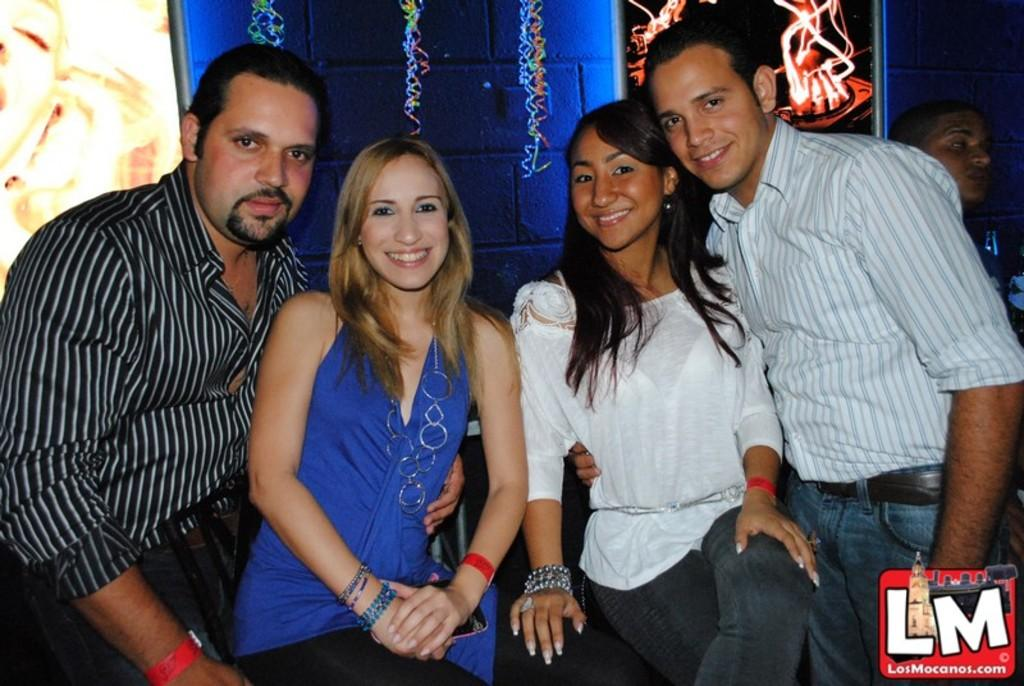How many people are present in the image? There are four people in the image, two women and two men. What can be seen in the bottom right corner of the image? There is a logo in the bottom right corner of the image. What is visible in the background of the image? There is text and a wall in the background of the image. What type of cloth is draped over the goose in the image? There is no goose present in the image, and therefore no cloth draped over it. 